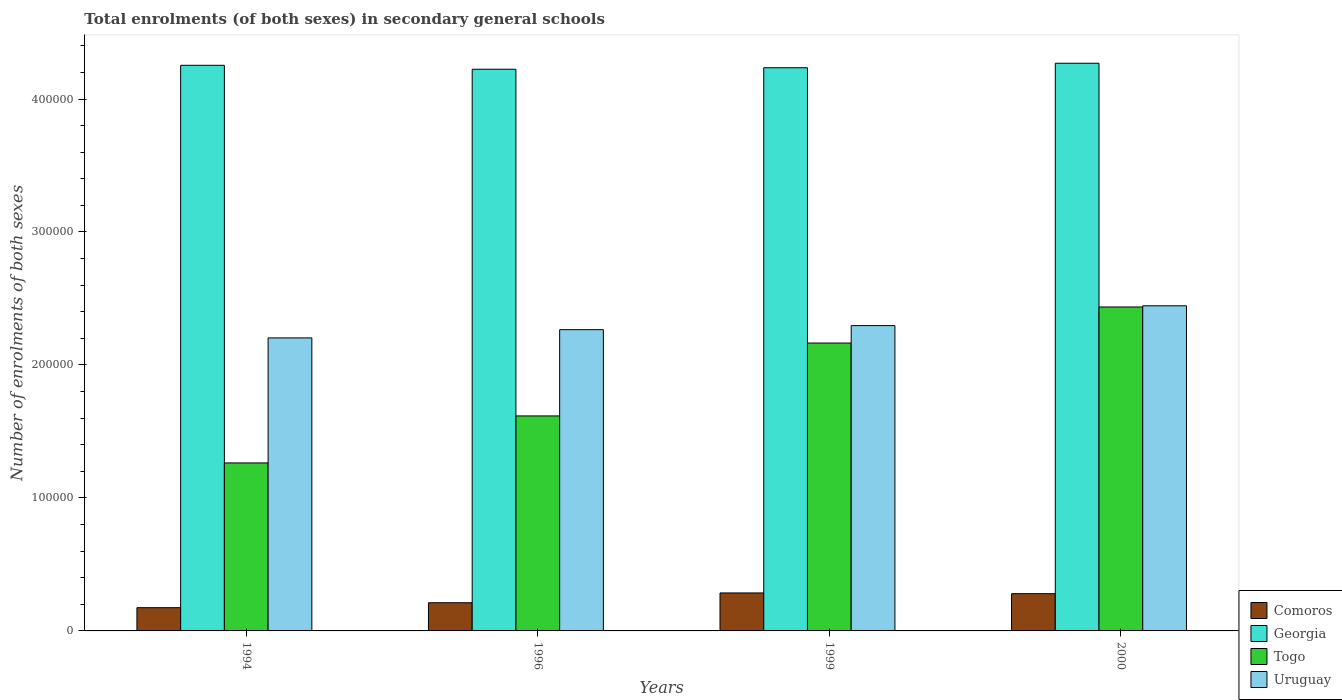How many different coloured bars are there?
Your response must be concise. 4. Are the number of bars on each tick of the X-axis equal?
Your response must be concise. Yes. How many bars are there on the 4th tick from the left?
Your answer should be compact. 4. How many bars are there on the 1st tick from the right?
Make the answer very short. 4. In how many cases, is the number of bars for a given year not equal to the number of legend labels?
Keep it short and to the point. 0. What is the number of enrolments in secondary schools in Comoros in 1996?
Provide a short and direct response. 2.12e+04. Across all years, what is the maximum number of enrolments in secondary schools in Comoros?
Give a very brief answer. 2.86e+04. Across all years, what is the minimum number of enrolments in secondary schools in Comoros?
Give a very brief answer. 1.75e+04. What is the total number of enrolments in secondary schools in Comoros in the graph?
Make the answer very short. 9.52e+04. What is the difference between the number of enrolments in secondary schools in Togo in 1996 and that in 1999?
Give a very brief answer. -5.48e+04. What is the difference between the number of enrolments in secondary schools in Uruguay in 1996 and the number of enrolments in secondary schools in Comoros in 1994?
Make the answer very short. 2.09e+05. What is the average number of enrolments in secondary schools in Uruguay per year?
Offer a very short reply. 2.30e+05. In the year 1994, what is the difference between the number of enrolments in secondary schools in Georgia and number of enrolments in secondary schools in Togo?
Offer a very short reply. 2.99e+05. What is the ratio of the number of enrolments in secondary schools in Uruguay in 1994 to that in 2000?
Provide a short and direct response. 0.9. What is the difference between the highest and the second highest number of enrolments in secondary schools in Georgia?
Your answer should be very brief. 1537. What is the difference between the highest and the lowest number of enrolments in secondary schools in Togo?
Offer a very short reply. 1.17e+05. In how many years, is the number of enrolments in secondary schools in Togo greater than the average number of enrolments in secondary schools in Togo taken over all years?
Give a very brief answer. 2. Is the sum of the number of enrolments in secondary schools in Comoros in 1996 and 1999 greater than the maximum number of enrolments in secondary schools in Uruguay across all years?
Offer a terse response. No. Is it the case that in every year, the sum of the number of enrolments in secondary schools in Comoros and number of enrolments in secondary schools in Uruguay is greater than the sum of number of enrolments in secondary schools in Togo and number of enrolments in secondary schools in Georgia?
Provide a short and direct response. No. What does the 1st bar from the left in 2000 represents?
Make the answer very short. Comoros. What does the 4th bar from the right in 1999 represents?
Make the answer very short. Comoros. How many bars are there?
Your answer should be very brief. 16. Are all the bars in the graph horizontal?
Keep it short and to the point. No. Are the values on the major ticks of Y-axis written in scientific E-notation?
Provide a short and direct response. No. Does the graph contain any zero values?
Your response must be concise. No. Does the graph contain grids?
Make the answer very short. No. Where does the legend appear in the graph?
Your response must be concise. Bottom right. How many legend labels are there?
Your answer should be compact. 4. What is the title of the graph?
Give a very brief answer. Total enrolments (of both sexes) in secondary general schools. What is the label or title of the X-axis?
Your answer should be very brief. Years. What is the label or title of the Y-axis?
Your answer should be compact. Number of enrolments of both sexes. What is the Number of enrolments of both sexes in Comoros in 1994?
Your response must be concise. 1.75e+04. What is the Number of enrolments of both sexes of Georgia in 1994?
Your response must be concise. 4.25e+05. What is the Number of enrolments of both sexes in Togo in 1994?
Keep it short and to the point. 1.26e+05. What is the Number of enrolments of both sexes in Uruguay in 1994?
Make the answer very short. 2.20e+05. What is the Number of enrolments of both sexes in Comoros in 1996?
Make the answer very short. 2.12e+04. What is the Number of enrolments of both sexes in Georgia in 1996?
Ensure brevity in your answer.  4.22e+05. What is the Number of enrolments of both sexes of Togo in 1996?
Give a very brief answer. 1.62e+05. What is the Number of enrolments of both sexes in Uruguay in 1996?
Your response must be concise. 2.27e+05. What is the Number of enrolments of both sexes in Comoros in 1999?
Provide a short and direct response. 2.86e+04. What is the Number of enrolments of both sexes of Georgia in 1999?
Provide a short and direct response. 4.24e+05. What is the Number of enrolments of both sexes in Togo in 1999?
Your response must be concise. 2.16e+05. What is the Number of enrolments of both sexes in Uruguay in 1999?
Ensure brevity in your answer.  2.30e+05. What is the Number of enrolments of both sexes in Comoros in 2000?
Offer a very short reply. 2.80e+04. What is the Number of enrolments of both sexes in Georgia in 2000?
Offer a very short reply. 4.27e+05. What is the Number of enrolments of both sexes of Togo in 2000?
Provide a succinct answer. 2.44e+05. What is the Number of enrolments of both sexes of Uruguay in 2000?
Give a very brief answer. 2.44e+05. Across all years, what is the maximum Number of enrolments of both sexes of Comoros?
Offer a terse response. 2.86e+04. Across all years, what is the maximum Number of enrolments of both sexes in Georgia?
Provide a short and direct response. 4.27e+05. Across all years, what is the maximum Number of enrolments of both sexes in Togo?
Offer a terse response. 2.44e+05. Across all years, what is the maximum Number of enrolments of both sexes of Uruguay?
Your answer should be compact. 2.44e+05. Across all years, what is the minimum Number of enrolments of both sexes of Comoros?
Make the answer very short. 1.75e+04. Across all years, what is the minimum Number of enrolments of both sexes of Georgia?
Provide a short and direct response. 4.22e+05. Across all years, what is the minimum Number of enrolments of both sexes of Togo?
Your response must be concise. 1.26e+05. Across all years, what is the minimum Number of enrolments of both sexes of Uruguay?
Provide a short and direct response. 2.20e+05. What is the total Number of enrolments of both sexes in Comoros in the graph?
Make the answer very short. 9.52e+04. What is the total Number of enrolments of both sexes of Georgia in the graph?
Offer a terse response. 1.70e+06. What is the total Number of enrolments of both sexes in Togo in the graph?
Your response must be concise. 7.48e+05. What is the total Number of enrolments of both sexes of Uruguay in the graph?
Offer a terse response. 9.21e+05. What is the difference between the Number of enrolments of both sexes of Comoros in 1994 and that in 1996?
Keep it short and to the point. -3718. What is the difference between the Number of enrolments of both sexes of Georgia in 1994 and that in 1996?
Your answer should be very brief. 2964. What is the difference between the Number of enrolments of both sexes of Togo in 1994 and that in 1996?
Give a very brief answer. -3.53e+04. What is the difference between the Number of enrolments of both sexes in Uruguay in 1994 and that in 1996?
Make the answer very short. -6189. What is the difference between the Number of enrolments of both sexes in Comoros in 1994 and that in 1999?
Offer a terse response. -1.11e+04. What is the difference between the Number of enrolments of both sexes in Georgia in 1994 and that in 1999?
Offer a terse response. 1835. What is the difference between the Number of enrolments of both sexes of Togo in 1994 and that in 1999?
Provide a succinct answer. -9.01e+04. What is the difference between the Number of enrolments of both sexes of Uruguay in 1994 and that in 1999?
Make the answer very short. -9244. What is the difference between the Number of enrolments of both sexes in Comoros in 1994 and that in 2000?
Give a very brief answer. -1.05e+04. What is the difference between the Number of enrolments of both sexes in Georgia in 1994 and that in 2000?
Provide a short and direct response. -1537. What is the difference between the Number of enrolments of both sexes in Togo in 1994 and that in 2000?
Keep it short and to the point. -1.17e+05. What is the difference between the Number of enrolments of both sexes of Uruguay in 1994 and that in 2000?
Offer a terse response. -2.41e+04. What is the difference between the Number of enrolments of both sexes of Comoros in 1996 and that in 1999?
Your response must be concise. -7367. What is the difference between the Number of enrolments of both sexes of Georgia in 1996 and that in 1999?
Ensure brevity in your answer.  -1129. What is the difference between the Number of enrolments of both sexes of Togo in 1996 and that in 1999?
Provide a succinct answer. -5.48e+04. What is the difference between the Number of enrolments of both sexes of Uruguay in 1996 and that in 1999?
Offer a terse response. -3055. What is the difference between the Number of enrolments of both sexes of Comoros in 1996 and that in 2000?
Provide a short and direct response. -6814. What is the difference between the Number of enrolments of both sexes in Georgia in 1996 and that in 2000?
Your answer should be compact. -4501. What is the difference between the Number of enrolments of both sexes in Togo in 1996 and that in 2000?
Ensure brevity in your answer.  -8.19e+04. What is the difference between the Number of enrolments of both sexes of Uruguay in 1996 and that in 2000?
Your answer should be very brief. -1.79e+04. What is the difference between the Number of enrolments of both sexes of Comoros in 1999 and that in 2000?
Your answer should be compact. 553. What is the difference between the Number of enrolments of both sexes of Georgia in 1999 and that in 2000?
Make the answer very short. -3372. What is the difference between the Number of enrolments of both sexes in Togo in 1999 and that in 2000?
Make the answer very short. -2.71e+04. What is the difference between the Number of enrolments of both sexes in Uruguay in 1999 and that in 2000?
Your answer should be compact. -1.49e+04. What is the difference between the Number of enrolments of both sexes of Comoros in 1994 and the Number of enrolments of both sexes of Georgia in 1996?
Provide a short and direct response. -4.05e+05. What is the difference between the Number of enrolments of both sexes of Comoros in 1994 and the Number of enrolments of both sexes of Togo in 1996?
Your response must be concise. -1.44e+05. What is the difference between the Number of enrolments of both sexes of Comoros in 1994 and the Number of enrolments of both sexes of Uruguay in 1996?
Offer a very short reply. -2.09e+05. What is the difference between the Number of enrolments of both sexes in Georgia in 1994 and the Number of enrolments of both sexes in Togo in 1996?
Provide a short and direct response. 2.64e+05. What is the difference between the Number of enrolments of both sexes of Georgia in 1994 and the Number of enrolments of both sexes of Uruguay in 1996?
Offer a very short reply. 1.99e+05. What is the difference between the Number of enrolments of both sexes of Togo in 1994 and the Number of enrolments of both sexes of Uruguay in 1996?
Offer a very short reply. -1.00e+05. What is the difference between the Number of enrolments of both sexes in Comoros in 1994 and the Number of enrolments of both sexes in Georgia in 1999?
Offer a terse response. -4.06e+05. What is the difference between the Number of enrolments of both sexes in Comoros in 1994 and the Number of enrolments of both sexes in Togo in 1999?
Offer a very short reply. -1.99e+05. What is the difference between the Number of enrolments of both sexes of Comoros in 1994 and the Number of enrolments of both sexes of Uruguay in 1999?
Offer a very short reply. -2.12e+05. What is the difference between the Number of enrolments of both sexes in Georgia in 1994 and the Number of enrolments of both sexes in Togo in 1999?
Provide a short and direct response. 2.09e+05. What is the difference between the Number of enrolments of both sexes in Georgia in 1994 and the Number of enrolments of both sexes in Uruguay in 1999?
Your response must be concise. 1.96e+05. What is the difference between the Number of enrolments of both sexes of Togo in 1994 and the Number of enrolments of both sexes of Uruguay in 1999?
Ensure brevity in your answer.  -1.03e+05. What is the difference between the Number of enrolments of both sexes in Comoros in 1994 and the Number of enrolments of both sexes in Georgia in 2000?
Offer a terse response. -4.09e+05. What is the difference between the Number of enrolments of both sexes in Comoros in 1994 and the Number of enrolments of both sexes in Togo in 2000?
Give a very brief answer. -2.26e+05. What is the difference between the Number of enrolments of both sexes in Comoros in 1994 and the Number of enrolments of both sexes in Uruguay in 2000?
Keep it short and to the point. -2.27e+05. What is the difference between the Number of enrolments of both sexes of Georgia in 1994 and the Number of enrolments of both sexes of Togo in 2000?
Keep it short and to the point. 1.82e+05. What is the difference between the Number of enrolments of both sexes in Georgia in 1994 and the Number of enrolments of both sexes in Uruguay in 2000?
Your answer should be very brief. 1.81e+05. What is the difference between the Number of enrolments of both sexes in Togo in 1994 and the Number of enrolments of both sexes in Uruguay in 2000?
Your response must be concise. -1.18e+05. What is the difference between the Number of enrolments of both sexes of Comoros in 1996 and the Number of enrolments of both sexes of Georgia in 1999?
Ensure brevity in your answer.  -4.02e+05. What is the difference between the Number of enrolments of both sexes in Comoros in 1996 and the Number of enrolments of both sexes in Togo in 1999?
Give a very brief answer. -1.95e+05. What is the difference between the Number of enrolments of both sexes of Comoros in 1996 and the Number of enrolments of both sexes of Uruguay in 1999?
Provide a succinct answer. -2.08e+05. What is the difference between the Number of enrolments of both sexes in Georgia in 1996 and the Number of enrolments of both sexes in Togo in 1999?
Your answer should be compact. 2.06e+05. What is the difference between the Number of enrolments of both sexes in Georgia in 1996 and the Number of enrolments of both sexes in Uruguay in 1999?
Keep it short and to the point. 1.93e+05. What is the difference between the Number of enrolments of both sexes of Togo in 1996 and the Number of enrolments of both sexes of Uruguay in 1999?
Your response must be concise. -6.79e+04. What is the difference between the Number of enrolments of both sexes of Comoros in 1996 and the Number of enrolments of both sexes of Georgia in 2000?
Make the answer very short. -4.06e+05. What is the difference between the Number of enrolments of both sexes of Comoros in 1996 and the Number of enrolments of both sexes of Togo in 2000?
Offer a very short reply. -2.22e+05. What is the difference between the Number of enrolments of both sexes of Comoros in 1996 and the Number of enrolments of both sexes of Uruguay in 2000?
Offer a very short reply. -2.23e+05. What is the difference between the Number of enrolments of both sexes in Georgia in 1996 and the Number of enrolments of both sexes in Togo in 2000?
Ensure brevity in your answer.  1.79e+05. What is the difference between the Number of enrolments of both sexes in Georgia in 1996 and the Number of enrolments of both sexes in Uruguay in 2000?
Your answer should be compact. 1.78e+05. What is the difference between the Number of enrolments of both sexes in Togo in 1996 and the Number of enrolments of both sexes in Uruguay in 2000?
Keep it short and to the point. -8.28e+04. What is the difference between the Number of enrolments of both sexes in Comoros in 1999 and the Number of enrolments of both sexes in Georgia in 2000?
Offer a terse response. -3.98e+05. What is the difference between the Number of enrolments of both sexes in Comoros in 1999 and the Number of enrolments of both sexes in Togo in 2000?
Keep it short and to the point. -2.15e+05. What is the difference between the Number of enrolments of both sexes in Comoros in 1999 and the Number of enrolments of both sexes in Uruguay in 2000?
Keep it short and to the point. -2.16e+05. What is the difference between the Number of enrolments of both sexes of Georgia in 1999 and the Number of enrolments of both sexes of Togo in 2000?
Offer a very short reply. 1.80e+05. What is the difference between the Number of enrolments of both sexes in Georgia in 1999 and the Number of enrolments of both sexes in Uruguay in 2000?
Offer a very short reply. 1.79e+05. What is the difference between the Number of enrolments of both sexes in Togo in 1999 and the Number of enrolments of both sexes in Uruguay in 2000?
Give a very brief answer. -2.80e+04. What is the average Number of enrolments of both sexes in Comoros per year?
Provide a short and direct response. 2.38e+04. What is the average Number of enrolments of both sexes in Georgia per year?
Provide a succinct answer. 4.25e+05. What is the average Number of enrolments of both sexes in Togo per year?
Your response must be concise. 1.87e+05. What is the average Number of enrolments of both sexes of Uruguay per year?
Provide a short and direct response. 2.30e+05. In the year 1994, what is the difference between the Number of enrolments of both sexes in Comoros and Number of enrolments of both sexes in Georgia?
Offer a very short reply. -4.08e+05. In the year 1994, what is the difference between the Number of enrolments of both sexes of Comoros and Number of enrolments of both sexes of Togo?
Offer a very short reply. -1.09e+05. In the year 1994, what is the difference between the Number of enrolments of both sexes in Comoros and Number of enrolments of both sexes in Uruguay?
Offer a very short reply. -2.03e+05. In the year 1994, what is the difference between the Number of enrolments of both sexes of Georgia and Number of enrolments of both sexes of Togo?
Provide a short and direct response. 2.99e+05. In the year 1994, what is the difference between the Number of enrolments of both sexes of Georgia and Number of enrolments of both sexes of Uruguay?
Offer a very short reply. 2.05e+05. In the year 1994, what is the difference between the Number of enrolments of both sexes in Togo and Number of enrolments of both sexes in Uruguay?
Offer a terse response. -9.40e+04. In the year 1996, what is the difference between the Number of enrolments of both sexes of Comoros and Number of enrolments of both sexes of Georgia?
Your response must be concise. -4.01e+05. In the year 1996, what is the difference between the Number of enrolments of both sexes in Comoros and Number of enrolments of both sexes in Togo?
Provide a succinct answer. -1.40e+05. In the year 1996, what is the difference between the Number of enrolments of both sexes of Comoros and Number of enrolments of both sexes of Uruguay?
Ensure brevity in your answer.  -2.05e+05. In the year 1996, what is the difference between the Number of enrolments of both sexes in Georgia and Number of enrolments of both sexes in Togo?
Your response must be concise. 2.61e+05. In the year 1996, what is the difference between the Number of enrolments of both sexes in Georgia and Number of enrolments of both sexes in Uruguay?
Ensure brevity in your answer.  1.96e+05. In the year 1996, what is the difference between the Number of enrolments of both sexes in Togo and Number of enrolments of both sexes in Uruguay?
Provide a succinct answer. -6.49e+04. In the year 1999, what is the difference between the Number of enrolments of both sexes in Comoros and Number of enrolments of both sexes in Georgia?
Your answer should be very brief. -3.95e+05. In the year 1999, what is the difference between the Number of enrolments of both sexes of Comoros and Number of enrolments of both sexes of Togo?
Offer a very short reply. -1.88e+05. In the year 1999, what is the difference between the Number of enrolments of both sexes in Comoros and Number of enrolments of both sexes in Uruguay?
Make the answer very short. -2.01e+05. In the year 1999, what is the difference between the Number of enrolments of both sexes of Georgia and Number of enrolments of both sexes of Togo?
Make the answer very short. 2.07e+05. In the year 1999, what is the difference between the Number of enrolments of both sexes of Georgia and Number of enrolments of both sexes of Uruguay?
Offer a terse response. 1.94e+05. In the year 1999, what is the difference between the Number of enrolments of both sexes of Togo and Number of enrolments of both sexes of Uruguay?
Offer a terse response. -1.31e+04. In the year 2000, what is the difference between the Number of enrolments of both sexes of Comoros and Number of enrolments of both sexes of Georgia?
Make the answer very short. -3.99e+05. In the year 2000, what is the difference between the Number of enrolments of both sexes in Comoros and Number of enrolments of both sexes in Togo?
Your answer should be very brief. -2.16e+05. In the year 2000, what is the difference between the Number of enrolments of both sexes of Comoros and Number of enrolments of both sexes of Uruguay?
Give a very brief answer. -2.16e+05. In the year 2000, what is the difference between the Number of enrolments of both sexes in Georgia and Number of enrolments of both sexes in Togo?
Offer a terse response. 1.83e+05. In the year 2000, what is the difference between the Number of enrolments of both sexes of Georgia and Number of enrolments of both sexes of Uruguay?
Your answer should be very brief. 1.82e+05. In the year 2000, what is the difference between the Number of enrolments of both sexes in Togo and Number of enrolments of both sexes in Uruguay?
Offer a very short reply. -896. What is the ratio of the Number of enrolments of both sexes in Comoros in 1994 to that in 1996?
Offer a terse response. 0.82. What is the ratio of the Number of enrolments of both sexes of Georgia in 1994 to that in 1996?
Offer a very short reply. 1.01. What is the ratio of the Number of enrolments of both sexes in Togo in 1994 to that in 1996?
Your answer should be compact. 0.78. What is the ratio of the Number of enrolments of both sexes in Uruguay in 1994 to that in 1996?
Make the answer very short. 0.97. What is the ratio of the Number of enrolments of both sexes of Comoros in 1994 to that in 1999?
Offer a terse response. 0.61. What is the ratio of the Number of enrolments of both sexes of Georgia in 1994 to that in 1999?
Your answer should be very brief. 1. What is the ratio of the Number of enrolments of both sexes of Togo in 1994 to that in 1999?
Ensure brevity in your answer.  0.58. What is the ratio of the Number of enrolments of both sexes in Uruguay in 1994 to that in 1999?
Offer a very short reply. 0.96. What is the ratio of the Number of enrolments of both sexes of Comoros in 1994 to that in 2000?
Keep it short and to the point. 0.62. What is the ratio of the Number of enrolments of both sexes in Togo in 1994 to that in 2000?
Ensure brevity in your answer.  0.52. What is the ratio of the Number of enrolments of both sexes of Uruguay in 1994 to that in 2000?
Provide a succinct answer. 0.9. What is the ratio of the Number of enrolments of both sexes of Comoros in 1996 to that in 1999?
Your response must be concise. 0.74. What is the ratio of the Number of enrolments of both sexes in Togo in 1996 to that in 1999?
Make the answer very short. 0.75. What is the ratio of the Number of enrolments of both sexes in Uruguay in 1996 to that in 1999?
Ensure brevity in your answer.  0.99. What is the ratio of the Number of enrolments of both sexes in Comoros in 1996 to that in 2000?
Make the answer very short. 0.76. What is the ratio of the Number of enrolments of both sexes in Togo in 1996 to that in 2000?
Your answer should be very brief. 0.66. What is the ratio of the Number of enrolments of both sexes in Uruguay in 1996 to that in 2000?
Make the answer very short. 0.93. What is the ratio of the Number of enrolments of both sexes in Comoros in 1999 to that in 2000?
Your answer should be compact. 1.02. What is the ratio of the Number of enrolments of both sexes of Georgia in 1999 to that in 2000?
Offer a very short reply. 0.99. What is the ratio of the Number of enrolments of both sexes of Togo in 1999 to that in 2000?
Make the answer very short. 0.89. What is the ratio of the Number of enrolments of both sexes in Uruguay in 1999 to that in 2000?
Give a very brief answer. 0.94. What is the difference between the highest and the second highest Number of enrolments of both sexes in Comoros?
Keep it short and to the point. 553. What is the difference between the highest and the second highest Number of enrolments of both sexes of Georgia?
Make the answer very short. 1537. What is the difference between the highest and the second highest Number of enrolments of both sexes in Togo?
Provide a succinct answer. 2.71e+04. What is the difference between the highest and the second highest Number of enrolments of both sexes in Uruguay?
Your answer should be very brief. 1.49e+04. What is the difference between the highest and the lowest Number of enrolments of both sexes of Comoros?
Ensure brevity in your answer.  1.11e+04. What is the difference between the highest and the lowest Number of enrolments of both sexes in Georgia?
Your answer should be very brief. 4501. What is the difference between the highest and the lowest Number of enrolments of both sexes of Togo?
Give a very brief answer. 1.17e+05. What is the difference between the highest and the lowest Number of enrolments of both sexes of Uruguay?
Provide a short and direct response. 2.41e+04. 